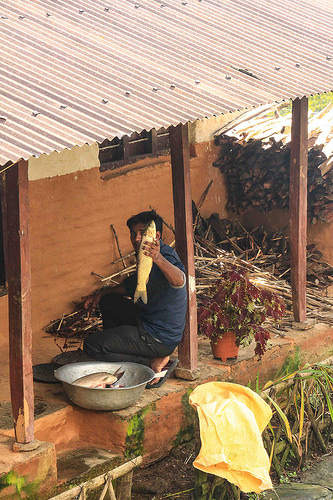<image>
Is there a bowl on the fish? No. The bowl is not positioned on the fish. They may be near each other, but the bowl is not supported by or resting on top of the fish. Is there a fish on the roof? No. The fish is not positioned on the roof. They may be near each other, but the fish is not supported by or resting on top of the roof. 